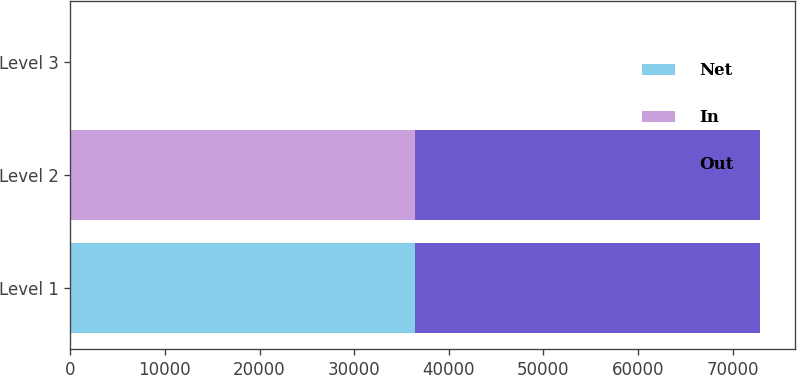Convert chart. <chart><loc_0><loc_0><loc_500><loc_500><stacked_bar_chart><ecel><fcel>Level 1<fcel>Level 2<fcel>Level 3<nl><fcel>Net<fcel>36468<fcel>0<fcel>0<nl><fcel>In<fcel>0<fcel>36468<fcel>0<nl><fcel>Out<fcel>36468<fcel>36468<fcel>0<nl></chart> 